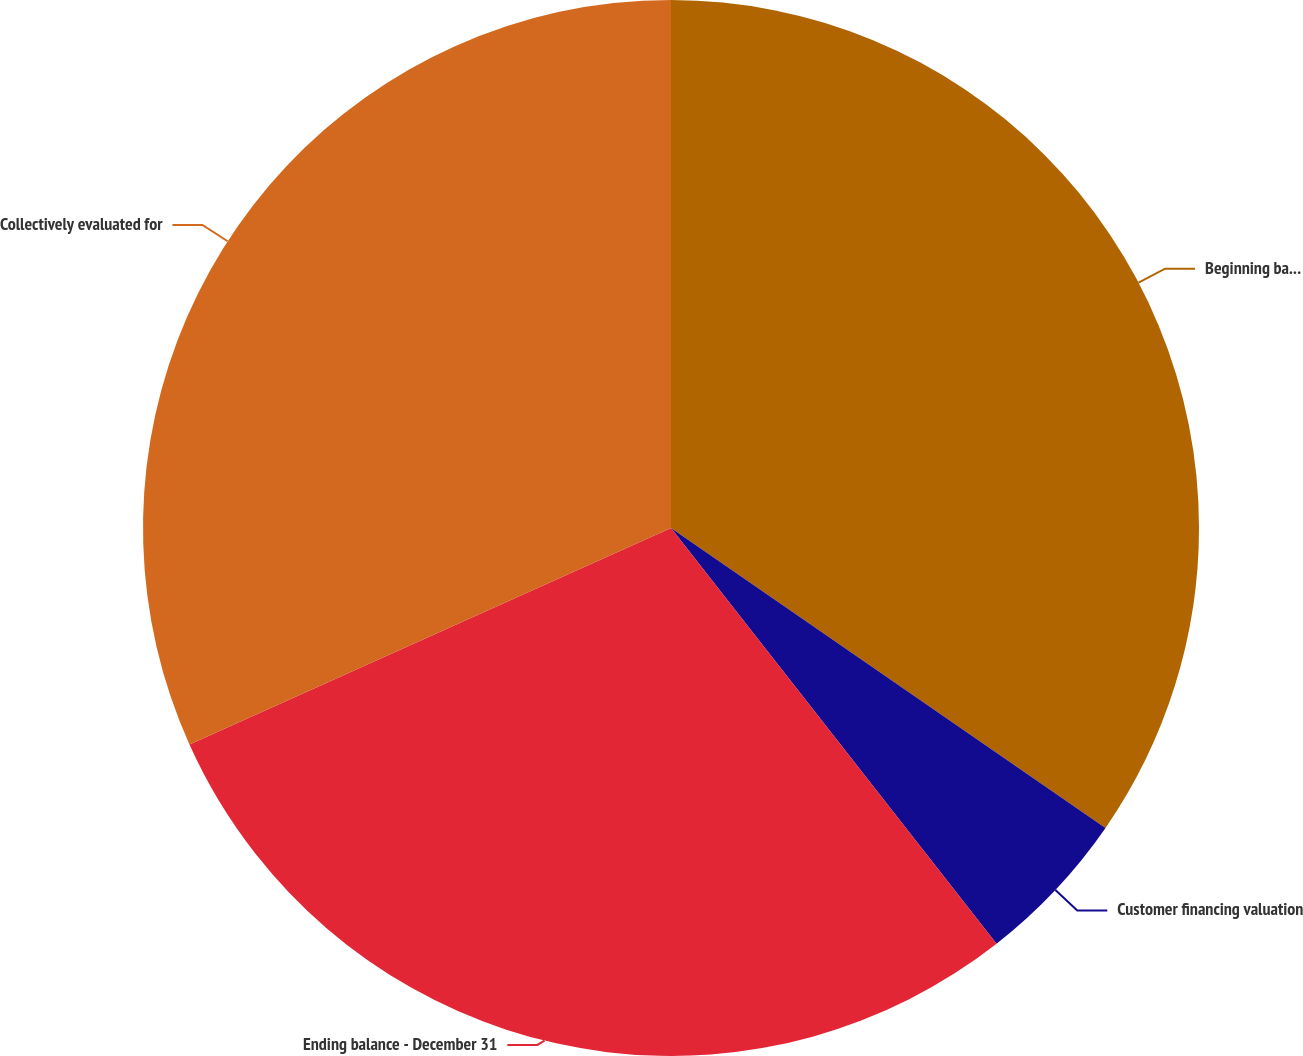<chart> <loc_0><loc_0><loc_500><loc_500><pie_chart><fcel>Beginning balance - January 1<fcel>Customer financing valuation<fcel>Ending balance - December 31<fcel>Collectively evaluated for<nl><fcel>34.62%<fcel>4.81%<fcel>28.85%<fcel>31.73%<nl></chart> 